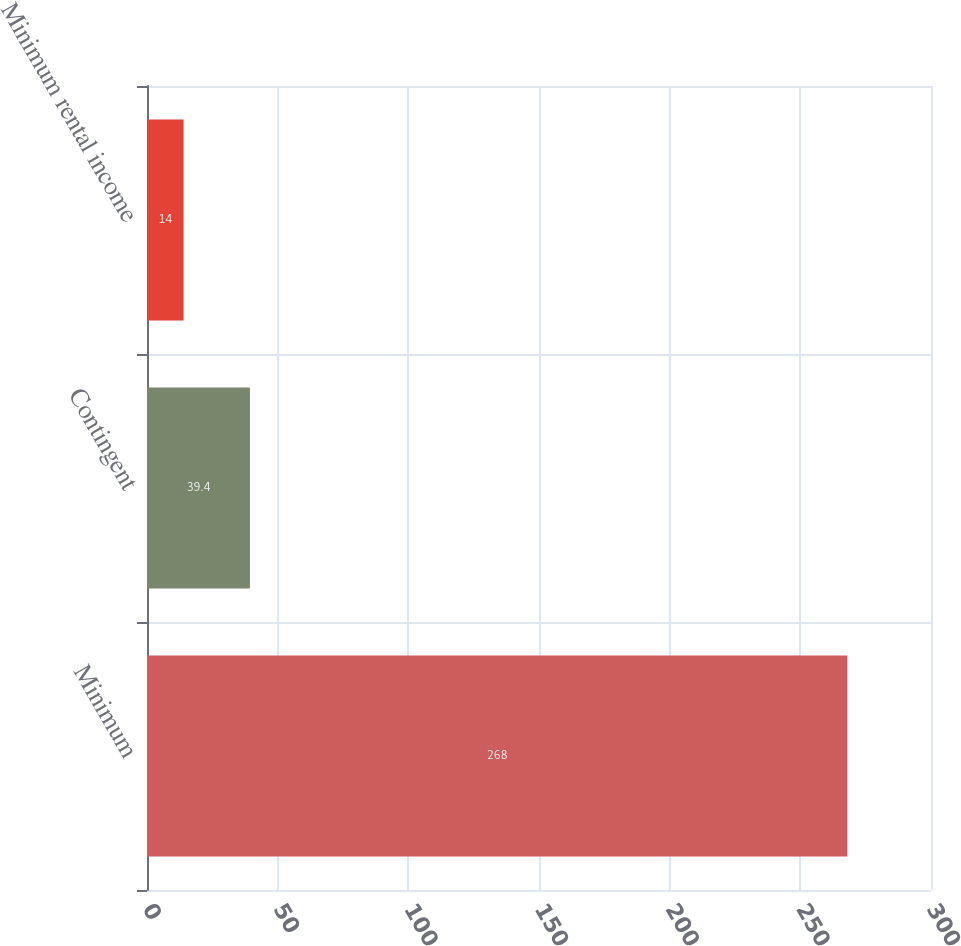Convert chart. <chart><loc_0><loc_0><loc_500><loc_500><bar_chart><fcel>Minimum<fcel>Contingent<fcel>Minimum rental income<nl><fcel>268<fcel>39.4<fcel>14<nl></chart> 